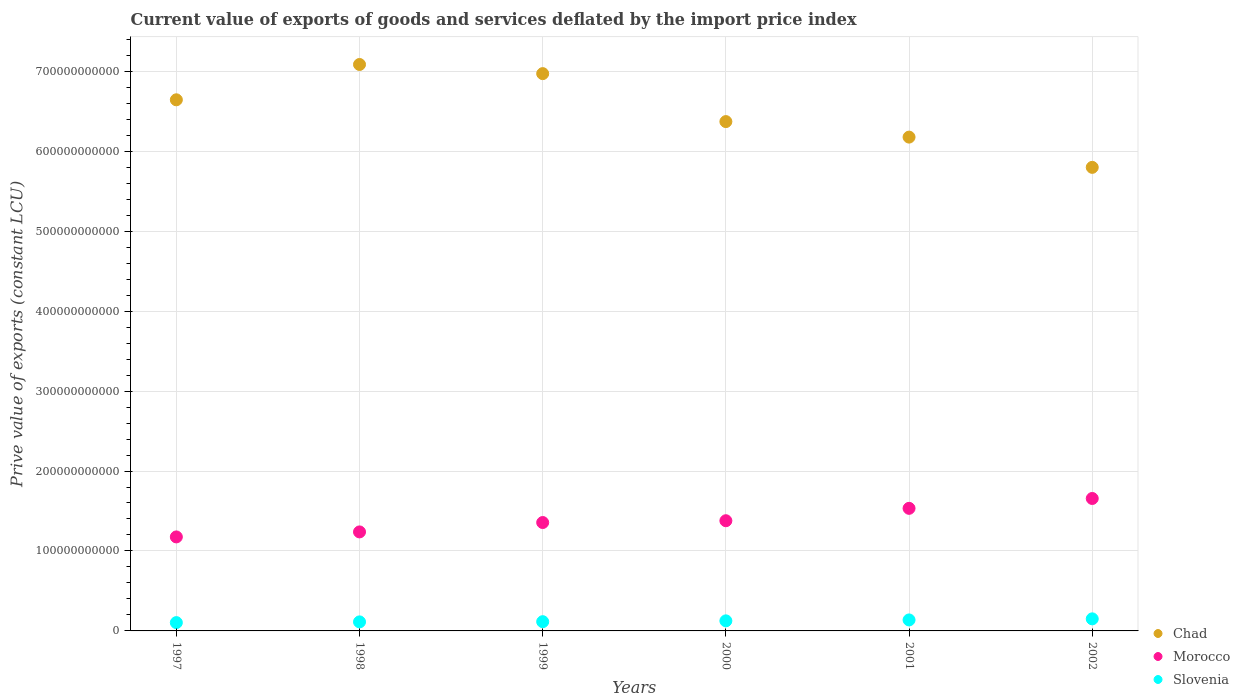Is the number of dotlines equal to the number of legend labels?
Offer a very short reply. Yes. What is the prive value of exports in Morocco in 1997?
Provide a short and direct response. 1.18e+11. Across all years, what is the maximum prive value of exports in Chad?
Your answer should be compact. 7.08e+11. Across all years, what is the minimum prive value of exports in Slovenia?
Your answer should be very brief. 1.04e+1. In which year was the prive value of exports in Morocco maximum?
Your answer should be compact. 2002. What is the total prive value of exports in Morocco in the graph?
Your response must be concise. 8.34e+11. What is the difference between the prive value of exports in Morocco in 1999 and that in 2000?
Your response must be concise. -2.25e+09. What is the difference between the prive value of exports in Slovenia in 1997 and the prive value of exports in Morocco in 2001?
Ensure brevity in your answer.  -1.43e+11. What is the average prive value of exports in Morocco per year?
Keep it short and to the point. 1.39e+11. In the year 2001, what is the difference between the prive value of exports in Slovenia and prive value of exports in Chad?
Ensure brevity in your answer.  -6.04e+11. In how many years, is the prive value of exports in Chad greater than 420000000000 LCU?
Keep it short and to the point. 6. What is the ratio of the prive value of exports in Chad in 1999 to that in 2001?
Give a very brief answer. 1.13. Is the difference between the prive value of exports in Slovenia in 1999 and 2002 greater than the difference between the prive value of exports in Chad in 1999 and 2002?
Provide a succinct answer. No. What is the difference between the highest and the second highest prive value of exports in Morocco?
Ensure brevity in your answer.  1.23e+1. What is the difference between the highest and the lowest prive value of exports in Chad?
Make the answer very short. 1.29e+11. How many dotlines are there?
Provide a short and direct response. 3. How many years are there in the graph?
Give a very brief answer. 6. What is the difference between two consecutive major ticks on the Y-axis?
Keep it short and to the point. 1.00e+11. Does the graph contain grids?
Your answer should be very brief. Yes. Where does the legend appear in the graph?
Give a very brief answer. Bottom right. How many legend labels are there?
Make the answer very short. 3. How are the legend labels stacked?
Ensure brevity in your answer.  Vertical. What is the title of the graph?
Ensure brevity in your answer.  Current value of exports of goods and services deflated by the import price index. Does "Eritrea" appear as one of the legend labels in the graph?
Your answer should be compact. No. What is the label or title of the X-axis?
Offer a terse response. Years. What is the label or title of the Y-axis?
Offer a terse response. Prive value of exports (constant LCU). What is the Prive value of exports (constant LCU) of Chad in 1997?
Provide a short and direct response. 6.64e+11. What is the Prive value of exports (constant LCU) in Morocco in 1997?
Provide a succinct answer. 1.18e+11. What is the Prive value of exports (constant LCU) of Slovenia in 1997?
Ensure brevity in your answer.  1.04e+1. What is the Prive value of exports (constant LCU) in Chad in 1998?
Your answer should be compact. 7.08e+11. What is the Prive value of exports (constant LCU) in Morocco in 1998?
Provide a succinct answer. 1.24e+11. What is the Prive value of exports (constant LCU) in Slovenia in 1998?
Your answer should be compact. 1.13e+1. What is the Prive value of exports (constant LCU) of Chad in 1999?
Provide a succinct answer. 6.97e+11. What is the Prive value of exports (constant LCU) of Morocco in 1999?
Keep it short and to the point. 1.36e+11. What is the Prive value of exports (constant LCU) of Slovenia in 1999?
Make the answer very short. 1.16e+1. What is the Prive value of exports (constant LCU) in Chad in 2000?
Ensure brevity in your answer.  6.37e+11. What is the Prive value of exports (constant LCU) in Morocco in 2000?
Keep it short and to the point. 1.38e+11. What is the Prive value of exports (constant LCU) of Slovenia in 2000?
Your answer should be compact. 1.26e+1. What is the Prive value of exports (constant LCU) in Chad in 2001?
Make the answer very short. 6.18e+11. What is the Prive value of exports (constant LCU) in Morocco in 2001?
Give a very brief answer. 1.53e+11. What is the Prive value of exports (constant LCU) in Slovenia in 2001?
Make the answer very short. 1.37e+1. What is the Prive value of exports (constant LCU) of Chad in 2002?
Give a very brief answer. 5.80e+11. What is the Prive value of exports (constant LCU) of Morocco in 2002?
Your response must be concise. 1.66e+11. What is the Prive value of exports (constant LCU) in Slovenia in 2002?
Your answer should be compact. 1.51e+1. Across all years, what is the maximum Prive value of exports (constant LCU) of Chad?
Give a very brief answer. 7.08e+11. Across all years, what is the maximum Prive value of exports (constant LCU) in Morocco?
Your answer should be very brief. 1.66e+11. Across all years, what is the maximum Prive value of exports (constant LCU) of Slovenia?
Provide a short and direct response. 1.51e+1. Across all years, what is the minimum Prive value of exports (constant LCU) of Chad?
Your answer should be compact. 5.80e+11. Across all years, what is the minimum Prive value of exports (constant LCU) of Morocco?
Your response must be concise. 1.18e+11. Across all years, what is the minimum Prive value of exports (constant LCU) in Slovenia?
Give a very brief answer. 1.04e+1. What is the total Prive value of exports (constant LCU) of Chad in the graph?
Ensure brevity in your answer.  3.90e+12. What is the total Prive value of exports (constant LCU) of Morocco in the graph?
Give a very brief answer. 8.34e+11. What is the total Prive value of exports (constant LCU) of Slovenia in the graph?
Provide a succinct answer. 7.47e+1. What is the difference between the Prive value of exports (constant LCU) in Chad in 1997 and that in 1998?
Ensure brevity in your answer.  -4.42e+1. What is the difference between the Prive value of exports (constant LCU) of Morocco in 1997 and that in 1998?
Your response must be concise. -6.26e+09. What is the difference between the Prive value of exports (constant LCU) in Slovenia in 1997 and that in 1998?
Make the answer very short. -9.15e+08. What is the difference between the Prive value of exports (constant LCU) of Chad in 1997 and that in 1999?
Provide a short and direct response. -3.27e+1. What is the difference between the Prive value of exports (constant LCU) in Morocco in 1997 and that in 1999?
Your response must be concise. -1.80e+1. What is the difference between the Prive value of exports (constant LCU) in Slovenia in 1997 and that in 1999?
Provide a succinct answer. -1.17e+09. What is the difference between the Prive value of exports (constant LCU) of Chad in 1997 and that in 2000?
Offer a terse response. 2.73e+1. What is the difference between the Prive value of exports (constant LCU) in Morocco in 1997 and that in 2000?
Your response must be concise. -2.03e+1. What is the difference between the Prive value of exports (constant LCU) in Slovenia in 1997 and that in 2000?
Provide a short and direct response. -2.22e+09. What is the difference between the Prive value of exports (constant LCU) of Chad in 1997 and that in 2001?
Your answer should be compact. 4.67e+1. What is the difference between the Prive value of exports (constant LCU) in Morocco in 1997 and that in 2001?
Offer a very short reply. -3.57e+1. What is the difference between the Prive value of exports (constant LCU) of Slovenia in 1997 and that in 2001?
Make the answer very short. -3.36e+09. What is the difference between the Prive value of exports (constant LCU) of Chad in 1997 and that in 2002?
Provide a succinct answer. 8.45e+1. What is the difference between the Prive value of exports (constant LCU) in Morocco in 1997 and that in 2002?
Provide a succinct answer. -4.81e+1. What is the difference between the Prive value of exports (constant LCU) of Slovenia in 1997 and that in 2002?
Provide a short and direct response. -4.71e+09. What is the difference between the Prive value of exports (constant LCU) in Chad in 1998 and that in 1999?
Give a very brief answer. 1.14e+1. What is the difference between the Prive value of exports (constant LCU) in Morocco in 1998 and that in 1999?
Make the answer very short. -1.17e+1. What is the difference between the Prive value of exports (constant LCU) of Slovenia in 1998 and that in 1999?
Ensure brevity in your answer.  -2.53e+08. What is the difference between the Prive value of exports (constant LCU) in Chad in 1998 and that in 2000?
Provide a short and direct response. 7.14e+1. What is the difference between the Prive value of exports (constant LCU) in Morocco in 1998 and that in 2000?
Your response must be concise. -1.40e+1. What is the difference between the Prive value of exports (constant LCU) in Slovenia in 1998 and that in 2000?
Provide a short and direct response. -1.30e+09. What is the difference between the Prive value of exports (constant LCU) in Chad in 1998 and that in 2001?
Provide a short and direct response. 9.08e+1. What is the difference between the Prive value of exports (constant LCU) of Morocco in 1998 and that in 2001?
Your answer should be compact. -2.95e+1. What is the difference between the Prive value of exports (constant LCU) of Slovenia in 1998 and that in 2001?
Give a very brief answer. -2.44e+09. What is the difference between the Prive value of exports (constant LCU) in Chad in 1998 and that in 2002?
Your answer should be very brief. 1.29e+11. What is the difference between the Prive value of exports (constant LCU) of Morocco in 1998 and that in 2002?
Ensure brevity in your answer.  -4.18e+1. What is the difference between the Prive value of exports (constant LCU) in Slovenia in 1998 and that in 2002?
Your answer should be very brief. -3.79e+09. What is the difference between the Prive value of exports (constant LCU) in Chad in 1999 and that in 2000?
Your response must be concise. 6.00e+1. What is the difference between the Prive value of exports (constant LCU) in Morocco in 1999 and that in 2000?
Your response must be concise. -2.25e+09. What is the difference between the Prive value of exports (constant LCU) of Slovenia in 1999 and that in 2000?
Keep it short and to the point. -1.05e+09. What is the difference between the Prive value of exports (constant LCU) of Chad in 1999 and that in 2001?
Your answer should be compact. 7.94e+1. What is the difference between the Prive value of exports (constant LCU) in Morocco in 1999 and that in 2001?
Your answer should be compact. -1.77e+1. What is the difference between the Prive value of exports (constant LCU) of Slovenia in 1999 and that in 2001?
Your answer should be compact. -2.19e+09. What is the difference between the Prive value of exports (constant LCU) in Chad in 1999 and that in 2002?
Your response must be concise. 1.17e+11. What is the difference between the Prive value of exports (constant LCU) in Morocco in 1999 and that in 2002?
Provide a succinct answer. -3.01e+1. What is the difference between the Prive value of exports (constant LCU) of Slovenia in 1999 and that in 2002?
Ensure brevity in your answer.  -3.54e+09. What is the difference between the Prive value of exports (constant LCU) in Chad in 2000 and that in 2001?
Your answer should be very brief. 1.94e+1. What is the difference between the Prive value of exports (constant LCU) of Morocco in 2000 and that in 2001?
Your answer should be very brief. -1.55e+1. What is the difference between the Prive value of exports (constant LCU) in Slovenia in 2000 and that in 2001?
Ensure brevity in your answer.  -1.14e+09. What is the difference between the Prive value of exports (constant LCU) of Chad in 2000 and that in 2002?
Offer a terse response. 5.72e+1. What is the difference between the Prive value of exports (constant LCU) in Morocco in 2000 and that in 2002?
Give a very brief answer. -2.78e+1. What is the difference between the Prive value of exports (constant LCU) of Slovenia in 2000 and that in 2002?
Your answer should be compact. -2.49e+09. What is the difference between the Prive value of exports (constant LCU) of Chad in 2001 and that in 2002?
Provide a short and direct response. 3.78e+1. What is the difference between the Prive value of exports (constant LCU) in Morocco in 2001 and that in 2002?
Provide a succinct answer. -1.23e+1. What is the difference between the Prive value of exports (constant LCU) of Slovenia in 2001 and that in 2002?
Your answer should be compact. -1.35e+09. What is the difference between the Prive value of exports (constant LCU) in Chad in 1997 and the Prive value of exports (constant LCU) in Morocco in 1998?
Make the answer very short. 5.40e+11. What is the difference between the Prive value of exports (constant LCU) of Chad in 1997 and the Prive value of exports (constant LCU) of Slovenia in 1998?
Provide a succinct answer. 6.53e+11. What is the difference between the Prive value of exports (constant LCU) of Morocco in 1997 and the Prive value of exports (constant LCU) of Slovenia in 1998?
Your answer should be compact. 1.06e+11. What is the difference between the Prive value of exports (constant LCU) in Chad in 1997 and the Prive value of exports (constant LCU) in Morocco in 1999?
Offer a terse response. 5.29e+11. What is the difference between the Prive value of exports (constant LCU) of Chad in 1997 and the Prive value of exports (constant LCU) of Slovenia in 1999?
Ensure brevity in your answer.  6.53e+11. What is the difference between the Prive value of exports (constant LCU) of Morocco in 1997 and the Prive value of exports (constant LCU) of Slovenia in 1999?
Make the answer very short. 1.06e+11. What is the difference between the Prive value of exports (constant LCU) in Chad in 1997 and the Prive value of exports (constant LCU) in Morocco in 2000?
Provide a succinct answer. 5.26e+11. What is the difference between the Prive value of exports (constant LCU) of Chad in 1997 and the Prive value of exports (constant LCU) of Slovenia in 2000?
Offer a terse response. 6.52e+11. What is the difference between the Prive value of exports (constant LCU) in Morocco in 1997 and the Prive value of exports (constant LCU) in Slovenia in 2000?
Ensure brevity in your answer.  1.05e+11. What is the difference between the Prive value of exports (constant LCU) of Chad in 1997 and the Prive value of exports (constant LCU) of Morocco in 2001?
Ensure brevity in your answer.  5.11e+11. What is the difference between the Prive value of exports (constant LCU) of Chad in 1997 and the Prive value of exports (constant LCU) of Slovenia in 2001?
Your response must be concise. 6.51e+11. What is the difference between the Prive value of exports (constant LCU) of Morocco in 1997 and the Prive value of exports (constant LCU) of Slovenia in 2001?
Keep it short and to the point. 1.04e+11. What is the difference between the Prive value of exports (constant LCU) in Chad in 1997 and the Prive value of exports (constant LCU) in Morocco in 2002?
Make the answer very short. 4.99e+11. What is the difference between the Prive value of exports (constant LCU) of Chad in 1997 and the Prive value of exports (constant LCU) of Slovenia in 2002?
Ensure brevity in your answer.  6.49e+11. What is the difference between the Prive value of exports (constant LCU) in Morocco in 1997 and the Prive value of exports (constant LCU) in Slovenia in 2002?
Offer a very short reply. 1.02e+11. What is the difference between the Prive value of exports (constant LCU) of Chad in 1998 and the Prive value of exports (constant LCU) of Morocco in 1999?
Provide a short and direct response. 5.73e+11. What is the difference between the Prive value of exports (constant LCU) in Chad in 1998 and the Prive value of exports (constant LCU) in Slovenia in 1999?
Provide a short and direct response. 6.97e+11. What is the difference between the Prive value of exports (constant LCU) in Morocco in 1998 and the Prive value of exports (constant LCU) in Slovenia in 1999?
Keep it short and to the point. 1.12e+11. What is the difference between the Prive value of exports (constant LCU) in Chad in 1998 and the Prive value of exports (constant LCU) in Morocco in 2000?
Provide a succinct answer. 5.71e+11. What is the difference between the Prive value of exports (constant LCU) in Chad in 1998 and the Prive value of exports (constant LCU) in Slovenia in 2000?
Provide a succinct answer. 6.96e+11. What is the difference between the Prive value of exports (constant LCU) of Morocco in 1998 and the Prive value of exports (constant LCU) of Slovenia in 2000?
Your response must be concise. 1.11e+11. What is the difference between the Prive value of exports (constant LCU) in Chad in 1998 and the Prive value of exports (constant LCU) in Morocco in 2001?
Ensure brevity in your answer.  5.55e+11. What is the difference between the Prive value of exports (constant LCU) in Chad in 1998 and the Prive value of exports (constant LCU) in Slovenia in 2001?
Provide a short and direct response. 6.95e+11. What is the difference between the Prive value of exports (constant LCU) in Morocco in 1998 and the Prive value of exports (constant LCU) in Slovenia in 2001?
Provide a succinct answer. 1.10e+11. What is the difference between the Prive value of exports (constant LCU) of Chad in 1998 and the Prive value of exports (constant LCU) of Morocco in 2002?
Your response must be concise. 5.43e+11. What is the difference between the Prive value of exports (constant LCU) in Chad in 1998 and the Prive value of exports (constant LCU) in Slovenia in 2002?
Keep it short and to the point. 6.93e+11. What is the difference between the Prive value of exports (constant LCU) of Morocco in 1998 and the Prive value of exports (constant LCU) of Slovenia in 2002?
Provide a short and direct response. 1.09e+11. What is the difference between the Prive value of exports (constant LCU) of Chad in 1999 and the Prive value of exports (constant LCU) of Morocco in 2000?
Provide a succinct answer. 5.59e+11. What is the difference between the Prive value of exports (constant LCU) of Chad in 1999 and the Prive value of exports (constant LCU) of Slovenia in 2000?
Your response must be concise. 6.84e+11. What is the difference between the Prive value of exports (constant LCU) in Morocco in 1999 and the Prive value of exports (constant LCU) in Slovenia in 2000?
Your answer should be compact. 1.23e+11. What is the difference between the Prive value of exports (constant LCU) in Chad in 1999 and the Prive value of exports (constant LCU) in Morocco in 2001?
Provide a short and direct response. 5.44e+11. What is the difference between the Prive value of exports (constant LCU) of Chad in 1999 and the Prive value of exports (constant LCU) of Slovenia in 2001?
Keep it short and to the point. 6.83e+11. What is the difference between the Prive value of exports (constant LCU) in Morocco in 1999 and the Prive value of exports (constant LCU) in Slovenia in 2001?
Your answer should be very brief. 1.22e+11. What is the difference between the Prive value of exports (constant LCU) in Chad in 1999 and the Prive value of exports (constant LCU) in Morocco in 2002?
Offer a terse response. 5.31e+11. What is the difference between the Prive value of exports (constant LCU) in Chad in 1999 and the Prive value of exports (constant LCU) in Slovenia in 2002?
Ensure brevity in your answer.  6.82e+11. What is the difference between the Prive value of exports (constant LCU) in Morocco in 1999 and the Prive value of exports (constant LCU) in Slovenia in 2002?
Provide a short and direct response. 1.20e+11. What is the difference between the Prive value of exports (constant LCU) in Chad in 2000 and the Prive value of exports (constant LCU) in Morocco in 2001?
Make the answer very short. 4.84e+11. What is the difference between the Prive value of exports (constant LCU) in Chad in 2000 and the Prive value of exports (constant LCU) in Slovenia in 2001?
Offer a terse response. 6.23e+11. What is the difference between the Prive value of exports (constant LCU) in Morocco in 2000 and the Prive value of exports (constant LCU) in Slovenia in 2001?
Provide a short and direct response. 1.24e+11. What is the difference between the Prive value of exports (constant LCU) of Chad in 2000 and the Prive value of exports (constant LCU) of Morocco in 2002?
Offer a terse response. 4.71e+11. What is the difference between the Prive value of exports (constant LCU) in Chad in 2000 and the Prive value of exports (constant LCU) in Slovenia in 2002?
Offer a terse response. 6.22e+11. What is the difference between the Prive value of exports (constant LCU) of Morocco in 2000 and the Prive value of exports (constant LCU) of Slovenia in 2002?
Ensure brevity in your answer.  1.23e+11. What is the difference between the Prive value of exports (constant LCU) of Chad in 2001 and the Prive value of exports (constant LCU) of Morocco in 2002?
Your answer should be very brief. 4.52e+11. What is the difference between the Prive value of exports (constant LCU) of Chad in 2001 and the Prive value of exports (constant LCU) of Slovenia in 2002?
Your answer should be very brief. 6.03e+11. What is the difference between the Prive value of exports (constant LCU) of Morocco in 2001 and the Prive value of exports (constant LCU) of Slovenia in 2002?
Offer a terse response. 1.38e+11. What is the average Prive value of exports (constant LCU) of Chad per year?
Offer a very short reply. 6.51e+11. What is the average Prive value of exports (constant LCU) in Morocco per year?
Offer a very short reply. 1.39e+11. What is the average Prive value of exports (constant LCU) of Slovenia per year?
Your answer should be very brief. 1.24e+1. In the year 1997, what is the difference between the Prive value of exports (constant LCU) of Chad and Prive value of exports (constant LCU) of Morocco?
Offer a very short reply. 5.47e+11. In the year 1997, what is the difference between the Prive value of exports (constant LCU) in Chad and Prive value of exports (constant LCU) in Slovenia?
Offer a very short reply. 6.54e+11. In the year 1997, what is the difference between the Prive value of exports (constant LCU) of Morocco and Prive value of exports (constant LCU) of Slovenia?
Offer a terse response. 1.07e+11. In the year 1998, what is the difference between the Prive value of exports (constant LCU) of Chad and Prive value of exports (constant LCU) of Morocco?
Provide a short and direct response. 5.85e+11. In the year 1998, what is the difference between the Prive value of exports (constant LCU) in Chad and Prive value of exports (constant LCU) in Slovenia?
Ensure brevity in your answer.  6.97e+11. In the year 1998, what is the difference between the Prive value of exports (constant LCU) of Morocco and Prive value of exports (constant LCU) of Slovenia?
Your response must be concise. 1.13e+11. In the year 1999, what is the difference between the Prive value of exports (constant LCU) in Chad and Prive value of exports (constant LCU) in Morocco?
Your answer should be compact. 5.61e+11. In the year 1999, what is the difference between the Prive value of exports (constant LCU) in Chad and Prive value of exports (constant LCU) in Slovenia?
Ensure brevity in your answer.  6.85e+11. In the year 1999, what is the difference between the Prive value of exports (constant LCU) of Morocco and Prive value of exports (constant LCU) of Slovenia?
Your response must be concise. 1.24e+11. In the year 2000, what is the difference between the Prive value of exports (constant LCU) of Chad and Prive value of exports (constant LCU) of Morocco?
Offer a terse response. 4.99e+11. In the year 2000, what is the difference between the Prive value of exports (constant LCU) in Chad and Prive value of exports (constant LCU) in Slovenia?
Your response must be concise. 6.24e+11. In the year 2000, what is the difference between the Prive value of exports (constant LCU) of Morocco and Prive value of exports (constant LCU) of Slovenia?
Your answer should be very brief. 1.25e+11. In the year 2001, what is the difference between the Prive value of exports (constant LCU) in Chad and Prive value of exports (constant LCU) in Morocco?
Your answer should be very brief. 4.64e+11. In the year 2001, what is the difference between the Prive value of exports (constant LCU) of Chad and Prive value of exports (constant LCU) of Slovenia?
Give a very brief answer. 6.04e+11. In the year 2001, what is the difference between the Prive value of exports (constant LCU) of Morocco and Prive value of exports (constant LCU) of Slovenia?
Your answer should be very brief. 1.40e+11. In the year 2002, what is the difference between the Prive value of exports (constant LCU) of Chad and Prive value of exports (constant LCU) of Morocco?
Your response must be concise. 4.14e+11. In the year 2002, what is the difference between the Prive value of exports (constant LCU) in Chad and Prive value of exports (constant LCU) in Slovenia?
Provide a succinct answer. 5.65e+11. In the year 2002, what is the difference between the Prive value of exports (constant LCU) of Morocco and Prive value of exports (constant LCU) of Slovenia?
Your response must be concise. 1.51e+11. What is the ratio of the Prive value of exports (constant LCU) of Chad in 1997 to that in 1998?
Your answer should be compact. 0.94. What is the ratio of the Prive value of exports (constant LCU) in Morocco in 1997 to that in 1998?
Offer a terse response. 0.95. What is the ratio of the Prive value of exports (constant LCU) of Slovenia in 1997 to that in 1998?
Provide a short and direct response. 0.92. What is the ratio of the Prive value of exports (constant LCU) of Chad in 1997 to that in 1999?
Your response must be concise. 0.95. What is the ratio of the Prive value of exports (constant LCU) of Morocco in 1997 to that in 1999?
Keep it short and to the point. 0.87. What is the ratio of the Prive value of exports (constant LCU) in Slovenia in 1997 to that in 1999?
Provide a short and direct response. 0.9. What is the ratio of the Prive value of exports (constant LCU) of Chad in 1997 to that in 2000?
Your response must be concise. 1.04. What is the ratio of the Prive value of exports (constant LCU) in Morocco in 1997 to that in 2000?
Offer a terse response. 0.85. What is the ratio of the Prive value of exports (constant LCU) in Slovenia in 1997 to that in 2000?
Keep it short and to the point. 0.82. What is the ratio of the Prive value of exports (constant LCU) of Chad in 1997 to that in 2001?
Provide a succinct answer. 1.08. What is the ratio of the Prive value of exports (constant LCU) in Morocco in 1997 to that in 2001?
Offer a terse response. 0.77. What is the ratio of the Prive value of exports (constant LCU) of Slovenia in 1997 to that in 2001?
Your answer should be compact. 0.76. What is the ratio of the Prive value of exports (constant LCU) of Chad in 1997 to that in 2002?
Offer a terse response. 1.15. What is the ratio of the Prive value of exports (constant LCU) of Morocco in 1997 to that in 2002?
Your answer should be very brief. 0.71. What is the ratio of the Prive value of exports (constant LCU) of Slovenia in 1997 to that in 2002?
Give a very brief answer. 0.69. What is the ratio of the Prive value of exports (constant LCU) of Chad in 1998 to that in 1999?
Your answer should be compact. 1.02. What is the ratio of the Prive value of exports (constant LCU) in Morocco in 1998 to that in 1999?
Offer a terse response. 0.91. What is the ratio of the Prive value of exports (constant LCU) in Slovenia in 1998 to that in 1999?
Provide a short and direct response. 0.98. What is the ratio of the Prive value of exports (constant LCU) of Chad in 1998 to that in 2000?
Provide a short and direct response. 1.11. What is the ratio of the Prive value of exports (constant LCU) in Morocco in 1998 to that in 2000?
Keep it short and to the point. 0.9. What is the ratio of the Prive value of exports (constant LCU) of Slovenia in 1998 to that in 2000?
Offer a very short reply. 0.9. What is the ratio of the Prive value of exports (constant LCU) of Chad in 1998 to that in 2001?
Offer a terse response. 1.15. What is the ratio of the Prive value of exports (constant LCU) in Morocco in 1998 to that in 2001?
Keep it short and to the point. 0.81. What is the ratio of the Prive value of exports (constant LCU) of Slovenia in 1998 to that in 2001?
Offer a very short reply. 0.82. What is the ratio of the Prive value of exports (constant LCU) in Chad in 1998 to that in 2002?
Give a very brief answer. 1.22. What is the ratio of the Prive value of exports (constant LCU) in Morocco in 1998 to that in 2002?
Provide a succinct answer. 0.75. What is the ratio of the Prive value of exports (constant LCU) of Slovenia in 1998 to that in 2002?
Provide a succinct answer. 0.75. What is the ratio of the Prive value of exports (constant LCU) of Chad in 1999 to that in 2000?
Provide a short and direct response. 1.09. What is the ratio of the Prive value of exports (constant LCU) of Morocco in 1999 to that in 2000?
Provide a short and direct response. 0.98. What is the ratio of the Prive value of exports (constant LCU) in Chad in 1999 to that in 2001?
Give a very brief answer. 1.13. What is the ratio of the Prive value of exports (constant LCU) of Morocco in 1999 to that in 2001?
Your answer should be compact. 0.88. What is the ratio of the Prive value of exports (constant LCU) in Slovenia in 1999 to that in 2001?
Your answer should be compact. 0.84. What is the ratio of the Prive value of exports (constant LCU) in Chad in 1999 to that in 2002?
Keep it short and to the point. 1.2. What is the ratio of the Prive value of exports (constant LCU) in Morocco in 1999 to that in 2002?
Your response must be concise. 0.82. What is the ratio of the Prive value of exports (constant LCU) of Slovenia in 1999 to that in 2002?
Give a very brief answer. 0.77. What is the ratio of the Prive value of exports (constant LCU) of Chad in 2000 to that in 2001?
Ensure brevity in your answer.  1.03. What is the ratio of the Prive value of exports (constant LCU) in Morocco in 2000 to that in 2001?
Offer a terse response. 0.9. What is the ratio of the Prive value of exports (constant LCU) in Slovenia in 2000 to that in 2001?
Your answer should be very brief. 0.92. What is the ratio of the Prive value of exports (constant LCU) of Chad in 2000 to that in 2002?
Make the answer very short. 1.1. What is the ratio of the Prive value of exports (constant LCU) in Morocco in 2000 to that in 2002?
Your response must be concise. 0.83. What is the ratio of the Prive value of exports (constant LCU) in Slovenia in 2000 to that in 2002?
Your answer should be very brief. 0.84. What is the ratio of the Prive value of exports (constant LCU) in Chad in 2001 to that in 2002?
Your answer should be very brief. 1.07. What is the ratio of the Prive value of exports (constant LCU) in Morocco in 2001 to that in 2002?
Your response must be concise. 0.93. What is the ratio of the Prive value of exports (constant LCU) of Slovenia in 2001 to that in 2002?
Make the answer very short. 0.91. What is the difference between the highest and the second highest Prive value of exports (constant LCU) in Chad?
Your response must be concise. 1.14e+1. What is the difference between the highest and the second highest Prive value of exports (constant LCU) of Morocco?
Offer a very short reply. 1.23e+1. What is the difference between the highest and the second highest Prive value of exports (constant LCU) in Slovenia?
Offer a terse response. 1.35e+09. What is the difference between the highest and the lowest Prive value of exports (constant LCU) in Chad?
Your response must be concise. 1.29e+11. What is the difference between the highest and the lowest Prive value of exports (constant LCU) in Morocco?
Make the answer very short. 4.81e+1. What is the difference between the highest and the lowest Prive value of exports (constant LCU) of Slovenia?
Your answer should be very brief. 4.71e+09. 